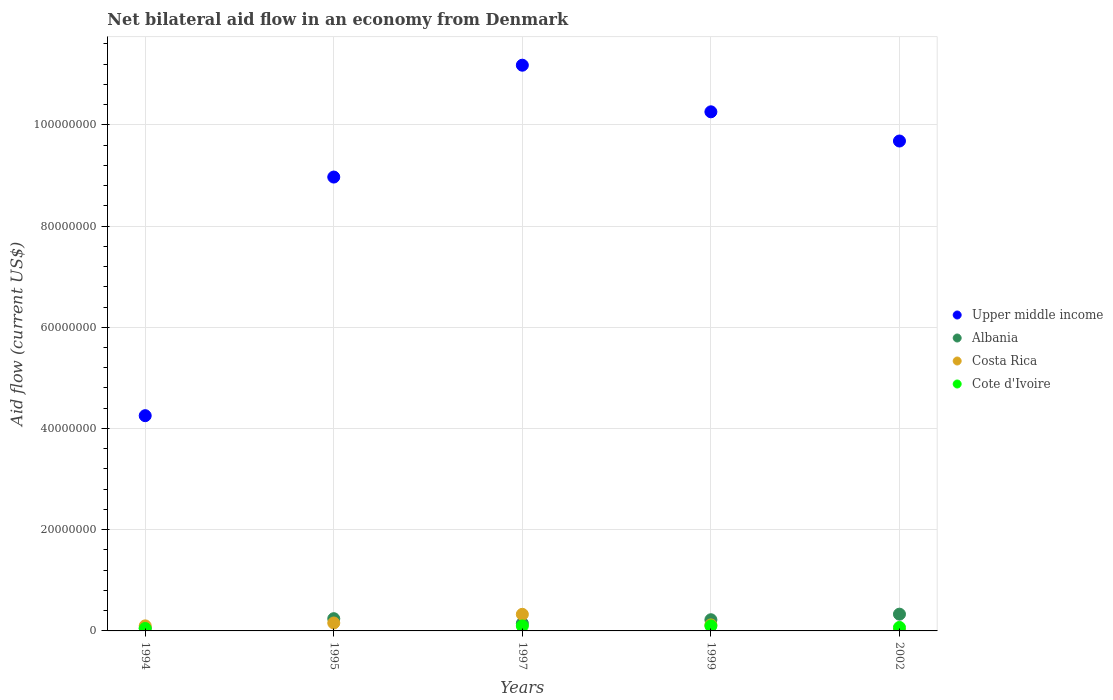Is the number of dotlines equal to the number of legend labels?
Provide a short and direct response. No. What is the net bilateral aid flow in Albania in 2002?
Keep it short and to the point. 3.31e+06. Across all years, what is the maximum net bilateral aid flow in Cote d'Ivoire?
Your response must be concise. 9.90e+05. Across all years, what is the minimum net bilateral aid flow in Cote d'Ivoire?
Provide a short and direct response. 0. What is the total net bilateral aid flow in Albania in the graph?
Your answer should be very brief. 9.99e+06. What is the difference between the net bilateral aid flow in Upper middle income in 1997 and that in 2002?
Provide a short and direct response. 1.50e+07. What is the difference between the net bilateral aid flow in Upper middle income in 1997 and the net bilateral aid flow in Albania in 1995?
Make the answer very short. 1.09e+08. What is the average net bilateral aid flow in Albania per year?
Offer a very short reply. 2.00e+06. In the year 1999, what is the difference between the net bilateral aid flow in Albania and net bilateral aid flow in Upper middle income?
Provide a short and direct response. -1.00e+08. In how many years, is the net bilateral aid flow in Cote d'Ivoire greater than 16000000 US$?
Keep it short and to the point. 0. What is the ratio of the net bilateral aid flow in Costa Rica in 1994 to that in 1999?
Your answer should be very brief. 0.84. Is the difference between the net bilateral aid flow in Albania in 1995 and 2002 greater than the difference between the net bilateral aid flow in Upper middle income in 1995 and 2002?
Your answer should be very brief. Yes. What is the difference between the highest and the second highest net bilateral aid flow in Costa Rica?
Keep it short and to the point. 1.71e+06. What is the difference between the highest and the lowest net bilateral aid flow in Upper middle income?
Provide a short and direct response. 6.92e+07. Is the sum of the net bilateral aid flow in Cote d'Ivoire in 1994 and 1997 greater than the maximum net bilateral aid flow in Upper middle income across all years?
Your response must be concise. No. Is it the case that in every year, the sum of the net bilateral aid flow in Cote d'Ivoire and net bilateral aid flow in Albania  is greater than the sum of net bilateral aid flow in Upper middle income and net bilateral aid flow in Costa Rica?
Keep it short and to the point. No. Is it the case that in every year, the sum of the net bilateral aid flow in Cote d'Ivoire and net bilateral aid flow in Costa Rica  is greater than the net bilateral aid flow in Upper middle income?
Give a very brief answer. No. What is the difference between two consecutive major ticks on the Y-axis?
Offer a terse response. 2.00e+07. Does the graph contain any zero values?
Provide a succinct answer. Yes. What is the title of the graph?
Keep it short and to the point. Net bilateral aid flow in an economy from Denmark. Does "Burkina Faso" appear as one of the legend labels in the graph?
Your answer should be compact. No. What is the label or title of the Y-axis?
Provide a short and direct response. Aid flow (current US$). What is the Aid flow (current US$) of Upper middle income in 1994?
Offer a very short reply. 4.25e+07. What is the Aid flow (current US$) in Albania in 1994?
Your response must be concise. 5.60e+05. What is the Aid flow (current US$) in Cote d'Ivoire in 1994?
Give a very brief answer. 4.80e+05. What is the Aid flow (current US$) of Upper middle income in 1995?
Make the answer very short. 8.97e+07. What is the Aid flow (current US$) in Albania in 1995?
Give a very brief answer. 2.42e+06. What is the Aid flow (current US$) in Costa Rica in 1995?
Keep it short and to the point. 1.57e+06. What is the Aid flow (current US$) of Cote d'Ivoire in 1995?
Offer a very short reply. 0. What is the Aid flow (current US$) of Upper middle income in 1997?
Provide a short and direct response. 1.12e+08. What is the Aid flow (current US$) of Albania in 1997?
Your answer should be very brief. 1.49e+06. What is the Aid flow (current US$) in Costa Rica in 1997?
Provide a succinct answer. 3.28e+06. What is the Aid flow (current US$) of Cote d'Ivoire in 1997?
Your response must be concise. 9.80e+05. What is the Aid flow (current US$) in Upper middle income in 1999?
Ensure brevity in your answer.  1.03e+08. What is the Aid flow (current US$) in Albania in 1999?
Ensure brevity in your answer.  2.21e+06. What is the Aid flow (current US$) of Costa Rica in 1999?
Provide a succinct answer. 1.19e+06. What is the Aid flow (current US$) in Cote d'Ivoire in 1999?
Your response must be concise. 9.90e+05. What is the Aid flow (current US$) in Upper middle income in 2002?
Your answer should be very brief. 9.68e+07. What is the Aid flow (current US$) in Albania in 2002?
Your answer should be compact. 3.31e+06. What is the Aid flow (current US$) of Cote d'Ivoire in 2002?
Offer a very short reply. 6.90e+05. Across all years, what is the maximum Aid flow (current US$) of Upper middle income?
Provide a short and direct response. 1.12e+08. Across all years, what is the maximum Aid flow (current US$) in Albania?
Provide a succinct answer. 3.31e+06. Across all years, what is the maximum Aid flow (current US$) in Costa Rica?
Your answer should be very brief. 3.28e+06. Across all years, what is the maximum Aid flow (current US$) of Cote d'Ivoire?
Your answer should be very brief. 9.90e+05. Across all years, what is the minimum Aid flow (current US$) in Upper middle income?
Your response must be concise. 4.25e+07. Across all years, what is the minimum Aid flow (current US$) in Albania?
Offer a very short reply. 5.60e+05. Across all years, what is the minimum Aid flow (current US$) of Cote d'Ivoire?
Make the answer very short. 0. What is the total Aid flow (current US$) of Upper middle income in the graph?
Give a very brief answer. 4.43e+08. What is the total Aid flow (current US$) of Albania in the graph?
Provide a short and direct response. 9.99e+06. What is the total Aid flow (current US$) of Costa Rica in the graph?
Your answer should be very brief. 7.07e+06. What is the total Aid flow (current US$) of Cote d'Ivoire in the graph?
Make the answer very short. 3.14e+06. What is the difference between the Aid flow (current US$) of Upper middle income in 1994 and that in 1995?
Provide a succinct answer. -4.72e+07. What is the difference between the Aid flow (current US$) in Albania in 1994 and that in 1995?
Provide a short and direct response. -1.86e+06. What is the difference between the Aid flow (current US$) in Costa Rica in 1994 and that in 1995?
Ensure brevity in your answer.  -5.70e+05. What is the difference between the Aid flow (current US$) of Upper middle income in 1994 and that in 1997?
Give a very brief answer. -6.92e+07. What is the difference between the Aid flow (current US$) in Albania in 1994 and that in 1997?
Offer a very short reply. -9.30e+05. What is the difference between the Aid flow (current US$) of Costa Rica in 1994 and that in 1997?
Provide a short and direct response. -2.28e+06. What is the difference between the Aid flow (current US$) of Cote d'Ivoire in 1994 and that in 1997?
Your response must be concise. -5.00e+05. What is the difference between the Aid flow (current US$) of Upper middle income in 1994 and that in 1999?
Your answer should be compact. -6.00e+07. What is the difference between the Aid flow (current US$) in Albania in 1994 and that in 1999?
Provide a short and direct response. -1.65e+06. What is the difference between the Aid flow (current US$) of Cote d'Ivoire in 1994 and that in 1999?
Offer a very short reply. -5.10e+05. What is the difference between the Aid flow (current US$) of Upper middle income in 1994 and that in 2002?
Your response must be concise. -5.43e+07. What is the difference between the Aid flow (current US$) in Albania in 1994 and that in 2002?
Provide a short and direct response. -2.75e+06. What is the difference between the Aid flow (current US$) in Costa Rica in 1994 and that in 2002?
Offer a terse response. 9.70e+05. What is the difference between the Aid flow (current US$) in Upper middle income in 1995 and that in 1997?
Keep it short and to the point. -2.21e+07. What is the difference between the Aid flow (current US$) in Albania in 1995 and that in 1997?
Keep it short and to the point. 9.30e+05. What is the difference between the Aid flow (current US$) of Costa Rica in 1995 and that in 1997?
Make the answer very short. -1.71e+06. What is the difference between the Aid flow (current US$) in Upper middle income in 1995 and that in 1999?
Offer a terse response. -1.29e+07. What is the difference between the Aid flow (current US$) in Upper middle income in 1995 and that in 2002?
Ensure brevity in your answer.  -7.12e+06. What is the difference between the Aid flow (current US$) in Albania in 1995 and that in 2002?
Offer a very short reply. -8.90e+05. What is the difference between the Aid flow (current US$) in Costa Rica in 1995 and that in 2002?
Your answer should be compact. 1.54e+06. What is the difference between the Aid flow (current US$) of Upper middle income in 1997 and that in 1999?
Provide a succinct answer. 9.21e+06. What is the difference between the Aid flow (current US$) in Albania in 1997 and that in 1999?
Your response must be concise. -7.20e+05. What is the difference between the Aid flow (current US$) of Costa Rica in 1997 and that in 1999?
Your answer should be very brief. 2.09e+06. What is the difference between the Aid flow (current US$) in Upper middle income in 1997 and that in 2002?
Offer a very short reply. 1.50e+07. What is the difference between the Aid flow (current US$) of Albania in 1997 and that in 2002?
Your response must be concise. -1.82e+06. What is the difference between the Aid flow (current US$) of Costa Rica in 1997 and that in 2002?
Provide a short and direct response. 3.25e+06. What is the difference between the Aid flow (current US$) in Cote d'Ivoire in 1997 and that in 2002?
Your answer should be very brief. 2.90e+05. What is the difference between the Aid flow (current US$) in Upper middle income in 1999 and that in 2002?
Provide a short and direct response. 5.77e+06. What is the difference between the Aid flow (current US$) in Albania in 1999 and that in 2002?
Make the answer very short. -1.10e+06. What is the difference between the Aid flow (current US$) of Costa Rica in 1999 and that in 2002?
Provide a succinct answer. 1.16e+06. What is the difference between the Aid flow (current US$) in Upper middle income in 1994 and the Aid flow (current US$) in Albania in 1995?
Your answer should be very brief. 4.01e+07. What is the difference between the Aid flow (current US$) of Upper middle income in 1994 and the Aid flow (current US$) of Costa Rica in 1995?
Offer a very short reply. 4.10e+07. What is the difference between the Aid flow (current US$) in Albania in 1994 and the Aid flow (current US$) in Costa Rica in 1995?
Offer a very short reply. -1.01e+06. What is the difference between the Aid flow (current US$) of Upper middle income in 1994 and the Aid flow (current US$) of Albania in 1997?
Your answer should be very brief. 4.10e+07. What is the difference between the Aid flow (current US$) in Upper middle income in 1994 and the Aid flow (current US$) in Costa Rica in 1997?
Give a very brief answer. 3.92e+07. What is the difference between the Aid flow (current US$) in Upper middle income in 1994 and the Aid flow (current US$) in Cote d'Ivoire in 1997?
Your answer should be very brief. 4.16e+07. What is the difference between the Aid flow (current US$) of Albania in 1994 and the Aid flow (current US$) of Costa Rica in 1997?
Make the answer very short. -2.72e+06. What is the difference between the Aid flow (current US$) in Albania in 1994 and the Aid flow (current US$) in Cote d'Ivoire in 1997?
Your answer should be very brief. -4.20e+05. What is the difference between the Aid flow (current US$) in Upper middle income in 1994 and the Aid flow (current US$) in Albania in 1999?
Provide a short and direct response. 4.03e+07. What is the difference between the Aid flow (current US$) of Upper middle income in 1994 and the Aid flow (current US$) of Costa Rica in 1999?
Your answer should be very brief. 4.13e+07. What is the difference between the Aid flow (current US$) of Upper middle income in 1994 and the Aid flow (current US$) of Cote d'Ivoire in 1999?
Offer a very short reply. 4.15e+07. What is the difference between the Aid flow (current US$) of Albania in 1994 and the Aid flow (current US$) of Costa Rica in 1999?
Ensure brevity in your answer.  -6.30e+05. What is the difference between the Aid flow (current US$) of Albania in 1994 and the Aid flow (current US$) of Cote d'Ivoire in 1999?
Ensure brevity in your answer.  -4.30e+05. What is the difference between the Aid flow (current US$) in Upper middle income in 1994 and the Aid flow (current US$) in Albania in 2002?
Your response must be concise. 3.92e+07. What is the difference between the Aid flow (current US$) of Upper middle income in 1994 and the Aid flow (current US$) of Costa Rica in 2002?
Give a very brief answer. 4.25e+07. What is the difference between the Aid flow (current US$) of Upper middle income in 1994 and the Aid flow (current US$) of Cote d'Ivoire in 2002?
Provide a succinct answer. 4.18e+07. What is the difference between the Aid flow (current US$) of Albania in 1994 and the Aid flow (current US$) of Costa Rica in 2002?
Give a very brief answer. 5.30e+05. What is the difference between the Aid flow (current US$) in Albania in 1994 and the Aid flow (current US$) in Cote d'Ivoire in 2002?
Make the answer very short. -1.30e+05. What is the difference between the Aid flow (current US$) in Costa Rica in 1994 and the Aid flow (current US$) in Cote d'Ivoire in 2002?
Your answer should be compact. 3.10e+05. What is the difference between the Aid flow (current US$) in Upper middle income in 1995 and the Aid flow (current US$) in Albania in 1997?
Provide a succinct answer. 8.82e+07. What is the difference between the Aid flow (current US$) of Upper middle income in 1995 and the Aid flow (current US$) of Costa Rica in 1997?
Offer a very short reply. 8.64e+07. What is the difference between the Aid flow (current US$) of Upper middle income in 1995 and the Aid flow (current US$) of Cote d'Ivoire in 1997?
Provide a succinct answer. 8.87e+07. What is the difference between the Aid flow (current US$) of Albania in 1995 and the Aid flow (current US$) of Costa Rica in 1997?
Your answer should be compact. -8.60e+05. What is the difference between the Aid flow (current US$) of Albania in 1995 and the Aid flow (current US$) of Cote d'Ivoire in 1997?
Your answer should be very brief. 1.44e+06. What is the difference between the Aid flow (current US$) in Costa Rica in 1995 and the Aid flow (current US$) in Cote d'Ivoire in 1997?
Your answer should be compact. 5.90e+05. What is the difference between the Aid flow (current US$) in Upper middle income in 1995 and the Aid flow (current US$) in Albania in 1999?
Make the answer very short. 8.75e+07. What is the difference between the Aid flow (current US$) of Upper middle income in 1995 and the Aid flow (current US$) of Costa Rica in 1999?
Give a very brief answer. 8.85e+07. What is the difference between the Aid flow (current US$) in Upper middle income in 1995 and the Aid flow (current US$) in Cote d'Ivoire in 1999?
Provide a succinct answer. 8.87e+07. What is the difference between the Aid flow (current US$) in Albania in 1995 and the Aid flow (current US$) in Costa Rica in 1999?
Give a very brief answer. 1.23e+06. What is the difference between the Aid flow (current US$) of Albania in 1995 and the Aid flow (current US$) of Cote d'Ivoire in 1999?
Keep it short and to the point. 1.43e+06. What is the difference between the Aid flow (current US$) of Costa Rica in 1995 and the Aid flow (current US$) of Cote d'Ivoire in 1999?
Provide a succinct answer. 5.80e+05. What is the difference between the Aid flow (current US$) in Upper middle income in 1995 and the Aid flow (current US$) in Albania in 2002?
Ensure brevity in your answer.  8.64e+07. What is the difference between the Aid flow (current US$) of Upper middle income in 1995 and the Aid flow (current US$) of Costa Rica in 2002?
Make the answer very short. 8.96e+07. What is the difference between the Aid flow (current US$) in Upper middle income in 1995 and the Aid flow (current US$) in Cote d'Ivoire in 2002?
Your response must be concise. 8.90e+07. What is the difference between the Aid flow (current US$) in Albania in 1995 and the Aid flow (current US$) in Costa Rica in 2002?
Offer a terse response. 2.39e+06. What is the difference between the Aid flow (current US$) of Albania in 1995 and the Aid flow (current US$) of Cote d'Ivoire in 2002?
Offer a very short reply. 1.73e+06. What is the difference between the Aid flow (current US$) in Costa Rica in 1995 and the Aid flow (current US$) in Cote d'Ivoire in 2002?
Keep it short and to the point. 8.80e+05. What is the difference between the Aid flow (current US$) of Upper middle income in 1997 and the Aid flow (current US$) of Albania in 1999?
Offer a very short reply. 1.10e+08. What is the difference between the Aid flow (current US$) in Upper middle income in 1997 and the Aid flow (current US$) in Costa Rica in 1999?
Offer a very short reply. 1.11e+08. What is the difference between the Aid flow (current US$) of Upper middle income in 1997 and the Aid flow (current US$) of Cote d'Ivoire in 1999?
Give a very brief answer. 1.11e+08. What is the difference between the Aid flow (current US$) in Albania in 1997 and the Aid flow (current US$) in Costa Rica in 1999?
Ensure brevity in your answer.  3.00e+05. What is the difference between the Aid flow (current US$) of Costa Rica in 1997 and the Aid flow (current US$) of Cote d'Ivoire in 1999?
Give a very brief answer. 2.29e+06. What is the difference between the Aid flow (current US$) in Upper middle income in 1997 and the Aid flow (current US$) in Albania in 2002?
Provide a short and direct response. 1.08e+08. What is the difference between the Aid flow (current US$) of Upper middle income in 1997 and the Aid flow (current US$) of Costa Rica in 2002?
Make the answer very short. 1.12e+08. What is the difference between the Aid flow (current US$) of Upper middle income in 1997 and the Aid flow (current US$) of Cote d'Ivoire in 2002?
Provide a short and direct response. 1.11e+08. What is the difference between the Aid flow (current US$) in Albania in 1997 and the Aid flow (current US$) in Costa Rica in 2002?
Your answer should be compact. 1.46e+06. What is the difference between the Aid flow (current US$) in Albania in 1997 and the Aid flow (current US$) in Cote d'Ivoire in 2002?
Ensure brevity in your answer.  8.00e+05. What is the difference between the Aid flow (current US$) in Costa Rica in 1997 and the Aid flow (current US$) in Cote d'Ivoire in 2002?
Ensure brevity in your answer.  2.59e+06. What is the difference between the Aid flow (current US$) of Upper middle income in 1999 and the Aid flow (current US$) of Albania in 2002?
Provide a succinct answer. 9.93e+07. What is the difference between the Aid flow (current US$) of Upper middle income in 1999 and the Aid flow (current US$) of Costa Rica in 2002?
Give a very brief answer. 1.03e+08. What is the difference between the Aid flow (current US$) in Upper middle income in 1999 and the Aid flow (current US$) in Cote d'Ivoire in 2002?
Your answer should be very brief. 1.02e+08. What is the difference between the Aid flow (current US$) of Albania in 1999 and the Aid flow (current US$) of Costa Rica in 2002?
Your answer should be very brief. 2.18e+06. What is the difference between the Aid flow (current US$) of Albania in 1999 and the Aid flow (current US$) of Cote d'Ivoire in 2002?
Offer a very short reply. 1.52e+06. What is the difference between the Aid flow (current US$) in Costa Rica in 1999 and the Aid flow (current US$) in Cote d'Ivoire in 2002?
Provide a short and direct response. 5.00e+05. What is the average Aid flow (current US$) of Upper middle income per year?
Give a very brief answer. 8.87e+07. What is the average Aid flow (current US$) of Albania per year?
Give a very brief answer. 2.00e+06. What is the average Aid flow (current US$) in Costa Rica per year?
Keep it short and to the point. 1.41e+06. What is the average Aid flow (current US$) in Cote d'Ivoire per year?
Make the answer very short. 6.28e+05. In the year 1994, what is the difference between the Aid flow (current US$) of Upper middle income and Aid flow (current US$) of Albania?
Provide a short and direct response. 4.20e+07. In the year 1994, what is the difference between the Aid flow (current US$) in Upper middle income and Aid flow (current US$) in Costa Rica?
Ensure brevity in your answer.  4.15e+07. In the year 1994, what is the difference between the Aid flow (current US$) of Upper middle income and Aid flow (current US$) of Cote d'Ivoire?
Provide a succinct answer. 4.20e+07. In the year 1994, what is the difference between the Aid flow (current US$) in Albania and Aid flow (current US$) in Costa Rica?
Offer a terse response. -4.40e+05. In the year 1994, what is the difference between the Aid flow (current US$) of Costa Rica and Aid flow (current US$) of Cote d'Ivoire?
Give a very brief answer. 5.20e+05. In the year 1995, what is the difference between the Aid flow (current US$) in Upper middle income and Aid flow (current US$) in Albania?
Your answer should be very brief. 8.73e+07. In the year 1995, what is the difference between the Aid flow (current US$) in Upper middle income and Aid flow (current US$) in Costa Rica?
Your response must be concise. 8.81e+07. In the year 1995, what is the difference between the Aid flow (current US$) in Albania and Aid flow (current US$) in Costa Rica?
Give a very brief answer. 8.50e+05. In the year 1997, what is the difference between the Aid flow (current US$) in Upper middle income and Aid flow (current US$) in Albania?
Make the answer very short. 1.10e+08. In the year 1997, what is the difference between the Aid flow (current US$) of Upper middle income and Aid flow (current US$) of Costa Rica?
Give a very brief answer. 1.08e+08. In the year 1997, what is the difference between the Aid flow (current US$) of Upper middle income and Aid flow (current US$) of Cote d'Ivoire?
Give a very brief answer. 1.11e+08. In the year 1997, what is the difference between the Aid flow (current US$) of Albania and Aid flow (current US$) of Costa Rica?
Provide a succinct answer. -1.79e+06. In the year 1997, what is the difference between the Aid flow (current US$) in Albania and Aid flow (current US$) in Cote d'Ivoire?
Offer a very short reply. 5.10e+05. In the year 1997, what is the difference between the Aid flow (current US$) of Costa Rica and Aid flow (current US$) of Cote d'Ivoire?
Your answer should be very brief. 2.30e+06. In the year 1999, what is the difference between the Aid flow (current US$) in Upper middle income and Aid flow (current US$) in Albania?
Offer a terse response. 1.00e+08. In the year 1999, what is the difference between the Aid flow (current US$) of Upper middle income and Aid flow (current US$) of Costa Rica?
Offer a terse response. 1.01e+08. In the year 1999, what is the difference between the Aid flow (current US$) of Upper middle income and Aid flow (current US$) of Cote d'Ivoire?
Ensure brevity in your answer.  1.02e+08. In the year 1999, what is the difference between the Aid flow (current US$) in Albania and Aid flow (current US$) in Costa Rica?
Your answer should be compact. 1.02e+06. In the year 1999, what is the difference between the Aid flow (current US$) of Albania and Aid flow (current US$) of Cote d'Ivoire?
Your answer should be compact. 1.22e+06. In the year 2002, what is the difference between the Aid flow (current US$) in Upper middle income and Aid flow (current US$) in Albania?
Ensure brevity in your answer.  9.35e+07. In the year 2002, what is the difference between the Aid flow (current US$) in Upper middle income and Aid flow (current US$) in Costa Rica?
Offer a very short reply. 9.68e+07. In the year 2002, what is the difference between the Aid flow (current US$) in Upper middle income and Aid flow (current US$) in Cote d'Ivoire?
Your answer should be very brief. 9.61e+07. In the year 2002, what is the difference between the Aid flow (current US$) of Albania and Aid flow (current US$) of Costa Rica?
Offer a very short reply. 3.28e+06. In the year 2002, what is the difference between the Aid flow (current US$) in Albania and Aid flow (current US$) in Cote d'Ivoire?
Offer a very short reply. 2.62e+06. In the year 2002, what is the difference between the Aid flow (current US$) in Costa Rica and Aid flow (current US$) in Cote d'Ivoire?
Offer a terse response. -6.60e+05. What is the ratio of the Aid flow (current US$) of Upper middle income in 1994 to that in 1995?
Make the answer very short. 0.47. What is the ratio of the Aid flow (current US$) in Albania in 1994 to that in 1995?
Offer a terse response. 0.23. What is the ratio of the Aid flow (current US$) of Costa Rica in 1994 to that in 1995?
Make the answer very short. 0.64. What is the ratio of the Aid flow (current US$) of Upper middle income in 1994 to that in 1997?
Your response must be concise. 0.38. What is the ratio of the Aid flow (current US$) of Albania in 1994 to that in 1997?
Provide a short and direct response. 0.38. What is the ratio of the Aid flow (current US$) in Costa Rica in 1994 to that in 1997?
Keep it short and to the point. 0.3. What is the ratio of the Aid flow (current US$) of Cote d'Ivoire in 1994 to that in 1997?
Your answer should be very brief. 0.49. What is the ratio of the Aid flow (current US$) in Upper middle income in 1994 to that in 1999?
Your answer should be compact. 0.41. What is the ratio of the Aid flow (current US$) in Albania in 1994 to that in 1999?
Your answer should be compact. 0.25. What is the ratio of the Aid flow (current US$) in Costa Rica in 1994 to that in 1999?
Offer a very short reply. 0.84. What is the ratio of the Aid flow (current US$) of Cote d'Ivoire in 1994 to that in 1999?
Offer a terse response. 0.48. What is the ratio of the Aid flow (current US$) in Upper middle income in 1994 to that in 2002?
Make the answer very short. 0.44. What is the ratio of the Aid flow (current US$) in Albania in 1994 to that in 2002?
Make the answer very short. 0.17. What is the ratio of the Aid flow (current US$) in Costa Rica in 1994 to that in 2002?
Offer a terse response. 33.33. What is the ratio of the Aid flow (current US$) of Cote d'Ivoire in 1994 to that in 2002?
Your response must be concise. 0.7. What is the ratio of the Aid flow (current US$) in Upper middle income in 1995 to that in 1997?
Offer a very short reply. 0.8. What is the ratio of the Aid flow (current US$) of Albania in 1995 to that in 1997?
Keep it short and to the point. 1.62. What is the ratio of the Aid flow (current US$) in Costa Rica in 1995 to that in 1997?
Provide a short and direct response. 0.48. What is the ratio of the Aid flow (current US$) in Upper middle income in 1995 to that in 1999?
Provide a succinct answer. 0.87. What is the ratio of the Aid flow (current US$) of Albania in 1995 to that in 1999?
Make the answer very short. 1.09. What is the ratio of the Aid flow (current US$) in Costa Rica in 1995 to that in 1999?
Provide a succinct answer. 1.32. What is the ratio of the Aid flow (current US$) of Upper middle income in 1995 to that in 2002?
Your answer should be very brief. 0.93. What is the ratio of the Aid flow (current US$) in Albania in 1995 to that in 2002?
Make the answer very short. 0.73. What is the ratio of the Aid flow (current US$) in Costa Rica in 1995 to that in 2002?
Offer a very short reply. 52.33. What is the ratio of the Aid flow (current US$) of Upper middle income in 1997 to that in 1999?
Your answer should be very brief. 1.09. What is the ratio of the Aid flow (current US$) in Albania in 1997 to that in 1999?
Your answer should be very brief. 0.67. What is the ratio of the Aid flow (current US$) of Costa Rica in 1997 to that in 1999?
Offer a terse response. 2.76. What is the ratio of the Aid flow (current US$) in Upper middle income in 1997 to that in 2002?
Offer a very short reply. 1.15. What is the ratio of the Aid flow (current US$) of Albania in 1997 to that in 2002?
Keep it short and to the point. 0.45. What is the ratio of the Aid flow (current US$) in Costa Rica in 1997 to that in 2002?
Your answer should be compact. 109.33. What is the ratio of the Aid flow (current US$) in Cote d'Ivoire in 1997 to that in 2002?
Offer a terse response. 1.42. What is the ratio of the Aid flow (current US$) in Upper middle income in 1999 to that in 2002?
Your answer should be very brief. 1.06. What is the ratio of the Aid flow (current US$) of Albania in 1999 to that in 2002?
Keep it short and to the point. 0.67. What is the ratio of the Aid flow (current US$) in Costa Rica in 1999 to that in 2002?
Make the answer very short. 39.67. What is the ratio of the Aid flow (current US$) in Cote d'Ivoire in 1999 to that in 2002?
Offer a very short reply. 1.43. What is the difference between the highest and the second highest Aid flow (current US$) of Upper middle income?
Offer a very short reply. 9.21e+06. What is the difference between the highest and the second highest Aid flow (current US$) in Albania?
Offer a very short reply. 8.90e+05. What is the difference between the highest and the second highest Aid flow (current US$) of Costa Rica?
Keep it short and to the point. 1.71e+06. What is the difference between the highest and the second highest Aid flow (current US$) in Cote d'Ivoire?
Offer a very short reply. 10000. What is the difference between the highest and the lowest Aid flow (current US$) in Upper middle income?
Offer a very short reply. 6.92e+07. What is the difference between the highest and the lowest Aid flow (current US$) of Albania?
Provide a succinct answer. 2.75e+06. What is the difference between the highest and the lowest Aid flow (current US$) in Costa Rica?
Offer a terse response. 3.25e+06. What is the difference between the highest and the lowest Aid flow (current US$) in Cote d'Ivoire?
Give a very brief answer. 9.90e+05. 